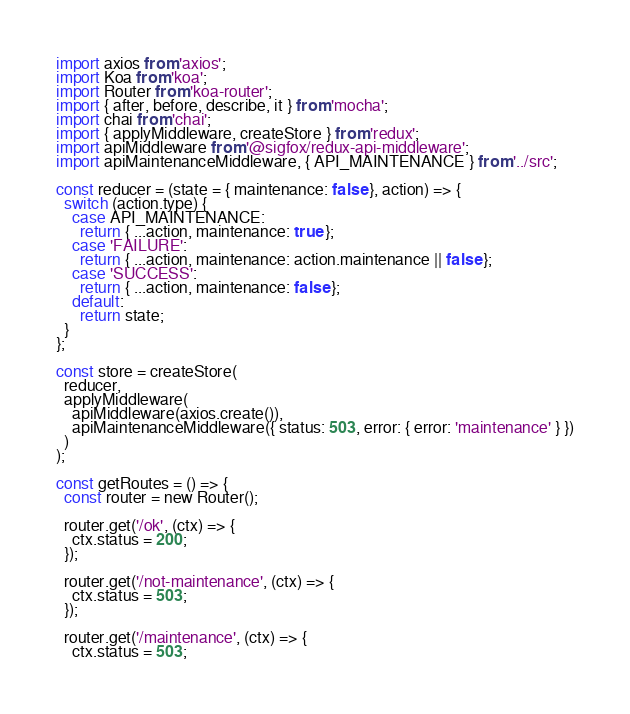<code> <loc_0><loc_0><loc_500><loc_500><_JavaScript_>import axios from 'axios';
import Koa from 'koa';
import Router from 'koa-router';
import { after, before, describe, it } from 'mocha';
import chai from 'chai';
import { applyMiddleware, createStore } from 'redux';
import apiMiddleware from '@sigfox/redux-api-middleware';
import apiMaintenanceMiddleware, { API_MAINTENANCE } from '../src';

const reducer = (state = { maintenance: false }, action) => {
  switch (action.type) {
    case API_MAINTENANCE:
      return { ...action, maintenance: true };
    case 'FAILURE':
      return { ...action, maintenance: action.maintenance || false };
    case 'SUCCESS':
      return { ...action, maintenance: false };
    default:
      return state;
  }
};

const store = createStore(
  reducer,
  applyMiddleware(
    apiMiddleware(axios.create()),
    apiMaintenanceMiddleware({ status: 503, error: { error: 'maintenance' } })
  )
);

const getRoutes = () => {
  const router = new Router();

  router.get('/ok', (ctx) => {
    ctx.status = 200;
  });

  router.get('/not-maintenance', (ctx) => {
    ctx.status = 503;
  });

  router.get('/maintenance', (ctx) => {
    ctx.status = 503;</code> 